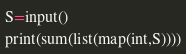Convert code to text. <code><loc_0><loc_0><loc_500><loc_500><_Python_>S=input()
print(sum(list(map(int,S))))
</code> 